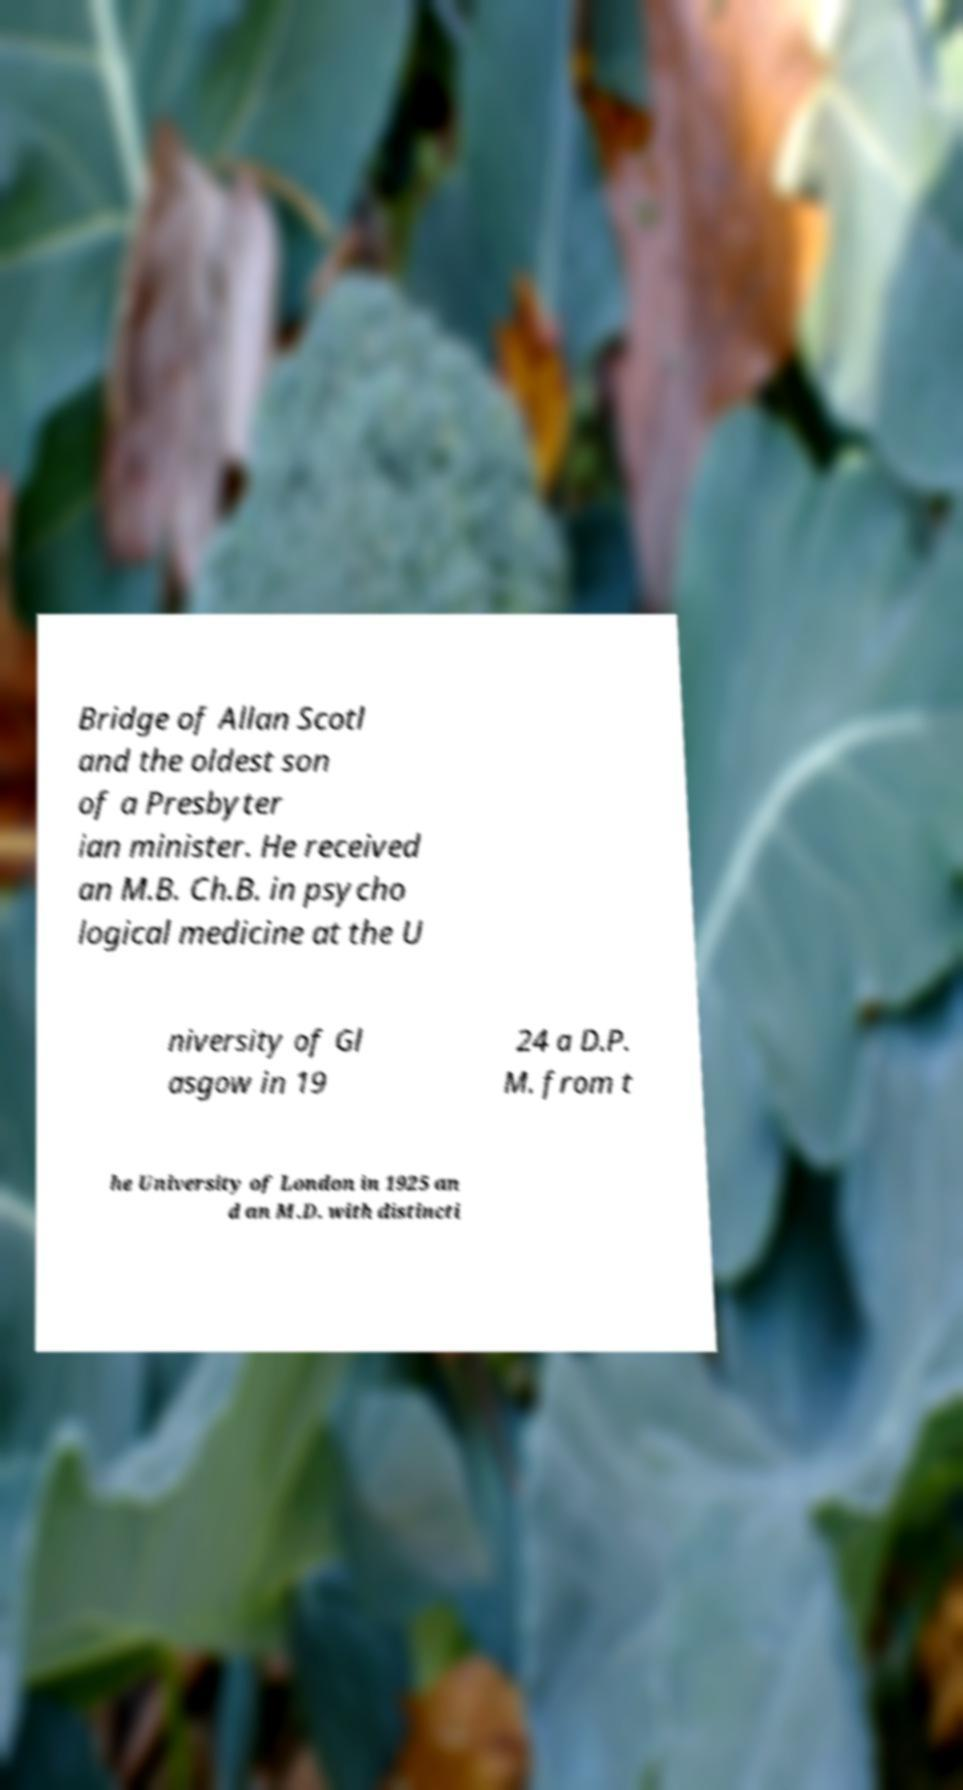Can you accurately transcribe the text from the provided image for me? Bridge of Allan Scotl and the oldest son of a Presbyter ian minister. He received an M.B. Ch.B. in psycho logical medicine at the U niversity of Gl asgow in 19 24 a D.P. M. from t he University of London in 1925 an d an M.D. with distincti 